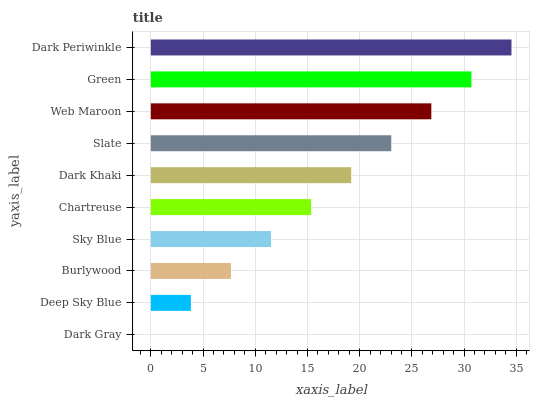Is Dark Gray the minimum?
Answer yes or no. Yes. Is Dark Periwinkle the maximum?
Answer yes or no. Yes. Is Deep Sky Blue the minimum?
Answer yes or no. No. Is Deep Sky Blue the maximum?
Answer yes or no. No. Is Deep Sky Blue greater than Dark Gray?
Answer yes or no. Yes. Is Dark Gray less than Deep Sky Blue?
Answer yes or no. Yes. Is Dark Gray greater than Deep Sky Blue?
Answer yes or no. No. Is Deep Sky Blue less than Dark Gray?
Answer yes or no. No. Is Dark Khaki the high median?
Answer yes or no. Yes. Is Chartreuse the low median?
Answer yes or no. Yes. Is Sky Blue the high median?
Answer yes or no. No. Is Web Maroon the low median?
Answer yes or no. No. 